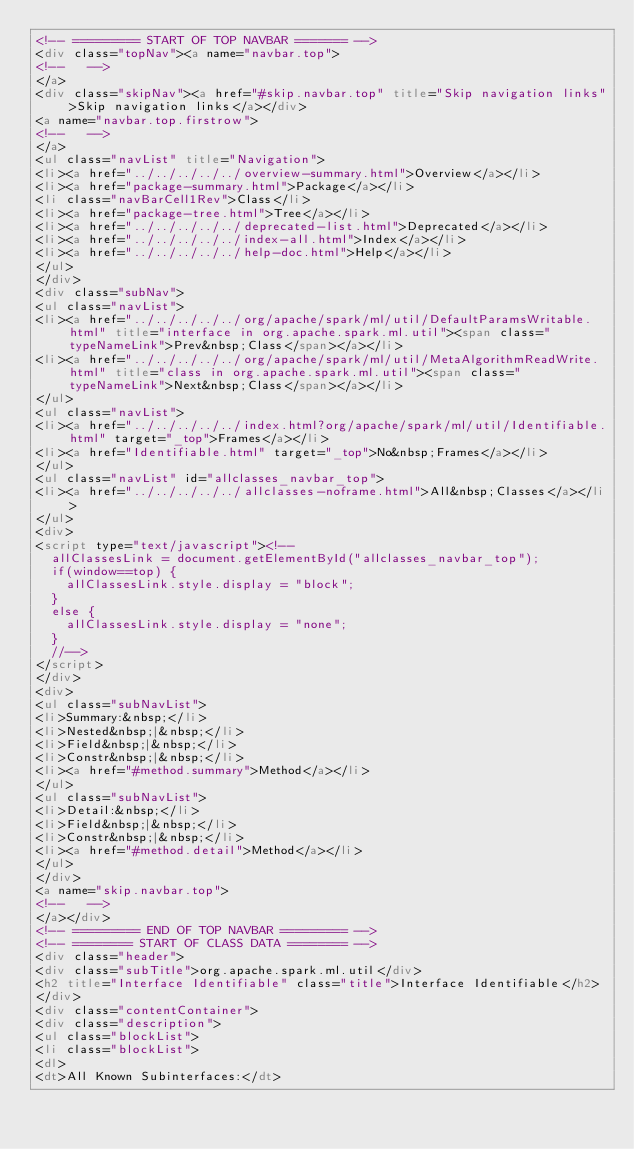<code> <loc_0><loc_0><loc_500><loc_500><_HTML_><!-- ========= START OF TOP NAVBAR ======= -->
<div class="topNav"><a name="navbar.top">
<!--   -->
</a>
<div class="skipNav"><a href="#skip.navbar.top" title="Skip navigation links">Skip navigation links</a></div>
<a name="navbar.top.firstrow">
<!--   -->
</a>
<ul class="navList" title="Navigation">
<li><a href="../../../../../overview-summary.html">Overview</a></li>
<li><a href="package-summary.html">Package</a></li>
<li class="navBarCell1Rev">Class</li>
<li><a href="package-tree.html">Tree</a></li>
<li><a href="../../../../../deprecated-list.html">Deprecated</a></li>
<li><a href="../../../../../index-all.html">Index</a></li>
<li><a href="../../../../../help-doc.html">Help</a></li>
</ul>
</div>
<div class="subNav">
<ul class="navList">
<li><a href="../../../../../org/apache/spark/ml/util/DefaultParamsWritable.html" title="interface in org.apache.spark.ml.util"><span class="typeNameLink">Prev&nbsp;Class</span></a></li>
<li><a href="../../../../../org/apache/spark/ml/util/MetaAlgorithmReadWrite.html" title="class in org.apache.spark.ml.util"><span class="typeNameLink">Next&nbsp;Class</span></a></li>
</ul>
<ul class="navList">
<li><a href="../../../../../index.html?org/apache/spark/ml/util/Identifiable.html" target="_top">Frames</a></li>
<li><a href="Identifiable.html" target="_top">No&nbsp;Frames</a></li>
</ul>
<ul class="navList" id="allclasses_navbar_top">
<li><a href="../../../../../allclasses-noframe.html">All&nbsp;Classes</a></li>
</ul>
<div>
<script type="text/javascript"><!--
  allClassesLink = document.getElementById("allclasses_navbar_top");
  if(window==top) {
    allClassesLink.style.display = "block";
  }
  else {
    allClassesLink.style.display = "none";
  }
  //-->
</script>
</div>
<div>
<ul class="subNavList">
<li>Summary:&nbsp;</li>
<li>Nested&nbsp;|&nbsp;</li>
<li>Field&nbsp;|&nbsp;</li>
<li>Constr&nbsp;|&nbsp;</li>
<li><a href="#method.summary">Method</a></li>
</ul>
<ul class="subNavList">
<li>Detail:&nbsp;</li>
<li>Field&nbsp;|&nbsp;</li>
<li>Constr&nbsp;|&nbsp;</li>
<li><a href="#method.detail">Method</a></li>
</ul>
</div>
<a name="skip.navbar.top">
<!--   -->
</a></div>
<!-- ========= END OF TOP NAVBAR ========= -->
<!-- ======== START OF CLASS DATA ======== -->
<div class="header">
<div class="subTitle">org.apache.spark.ml.util</div>
<h2 title="Interface Identifiable" class="title">Interface Identifiable</h2>
</div>
<div class="contentContainer">
<div class="description">
<ul class="blockList">
<li class="blockList">
<dl>
<dt>All Known Subinterfaces:</dt></code> 